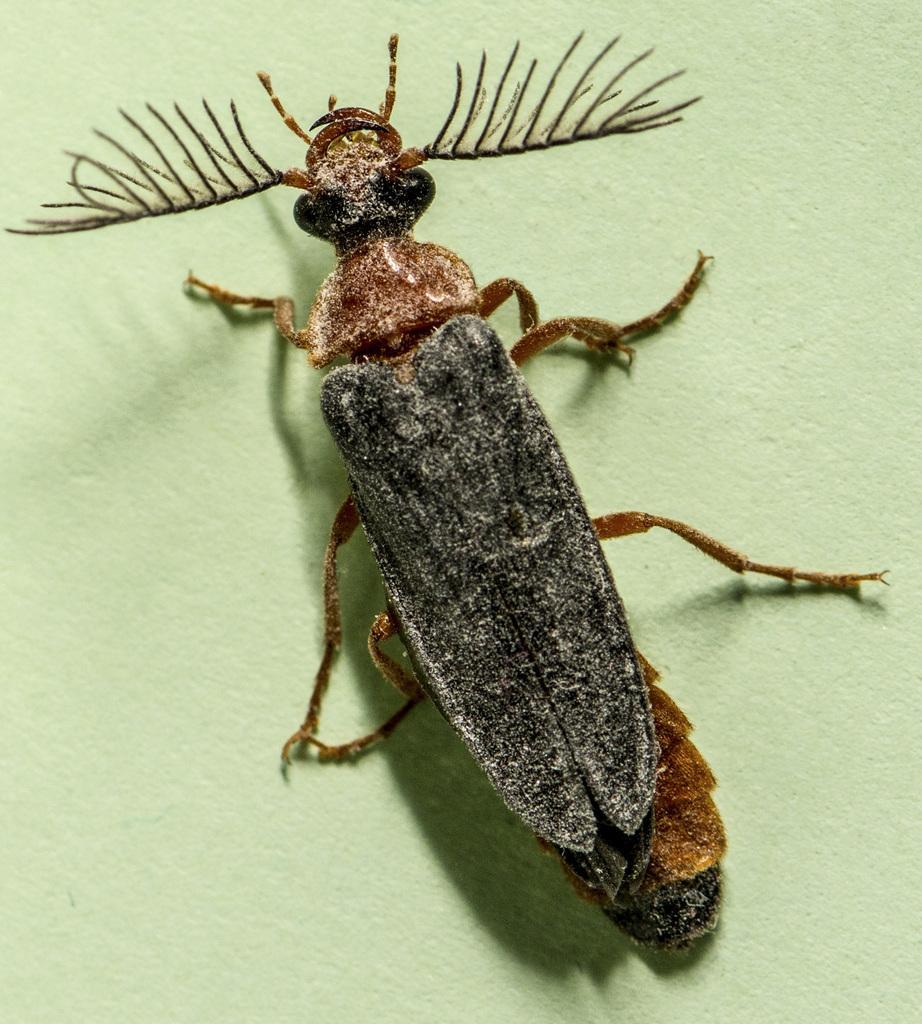Can you describe this image briefly? In this picture I can see an insect in the middle. 